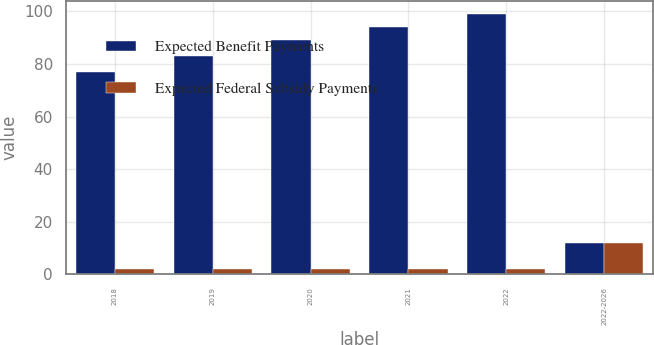<chart> <loc_0><loc_0><loc_500><loc_500><stacked_bar_chart><ecel><fcel>2018<fcel>2019<fcel>2020<fcel>2021<fcel>2022<fcel>2022-2026<nl><fcel>Expected Benefit Payments<fcel>77<fcel>83<fcel>89<fcel>94<fcel>99<fcel>12<nl><fcel>Expected Federal Subsidy Payments<fcel>2<fcel>2<fcel>2<fcel>2<fcel>2<fcel>12<nl></chart> 